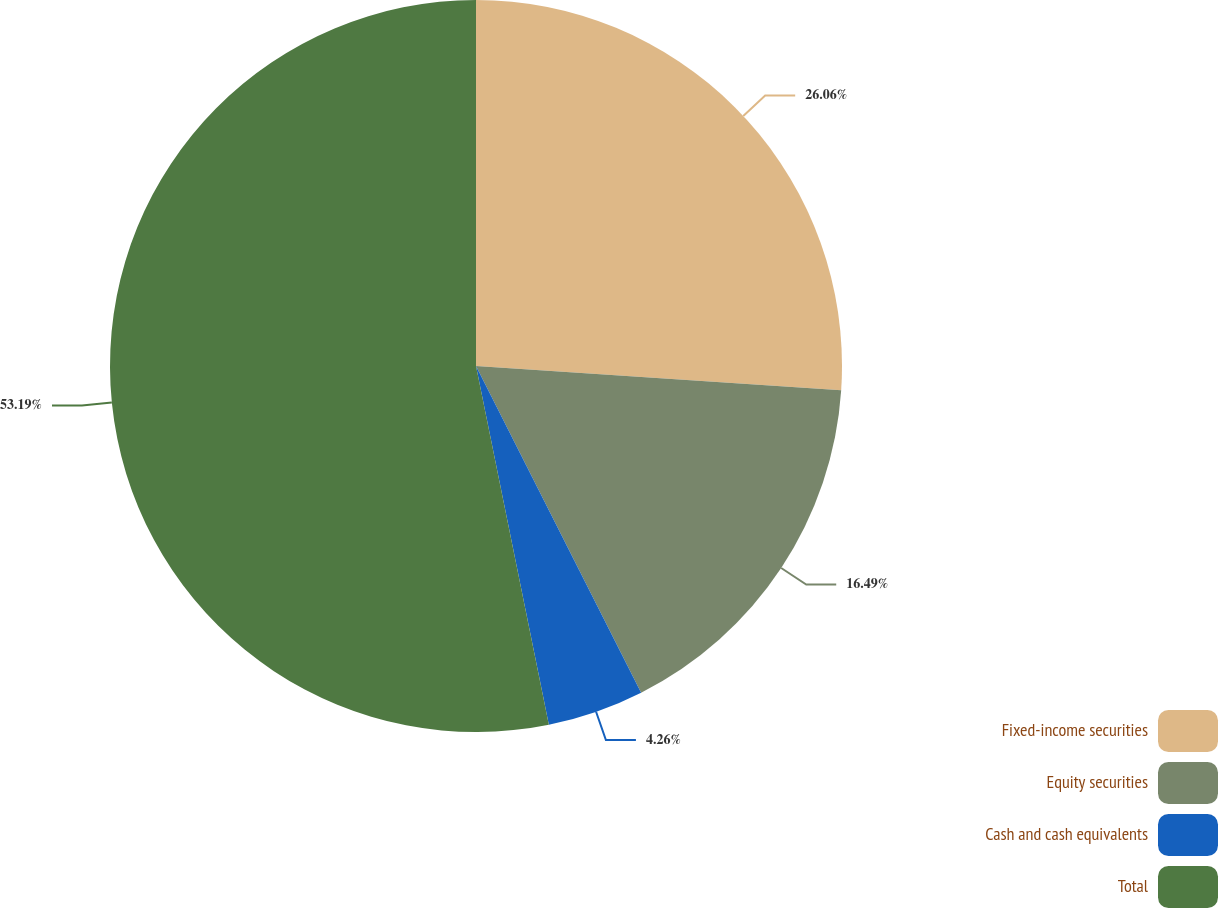Convert chart. <chart><loc_0><loc_0><loc_500><loc_500><pie_chart><fcel>Fixed-income securities<fcel>Equity securities<fcel>Cash and cash equivalents<fcel>Total<nl><fcel>26.06%<fcel>16.49%<fcel>4.26%<fcel>53.19%<nl></chart> 